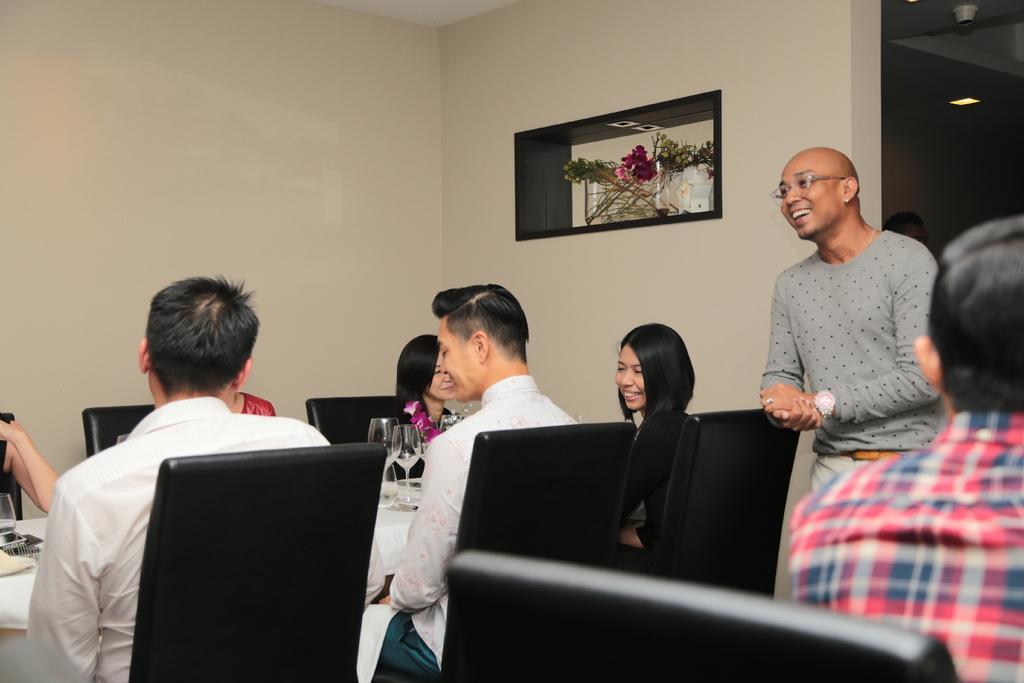Could you give a brief overview of what you see in this image? In the picture I can see a few persons sitting on the chairs and they are smiling. There is a man on the right side is standing on the floor and he is smiling as well. I can see the flowers. I can see the wine glasses on the table. 